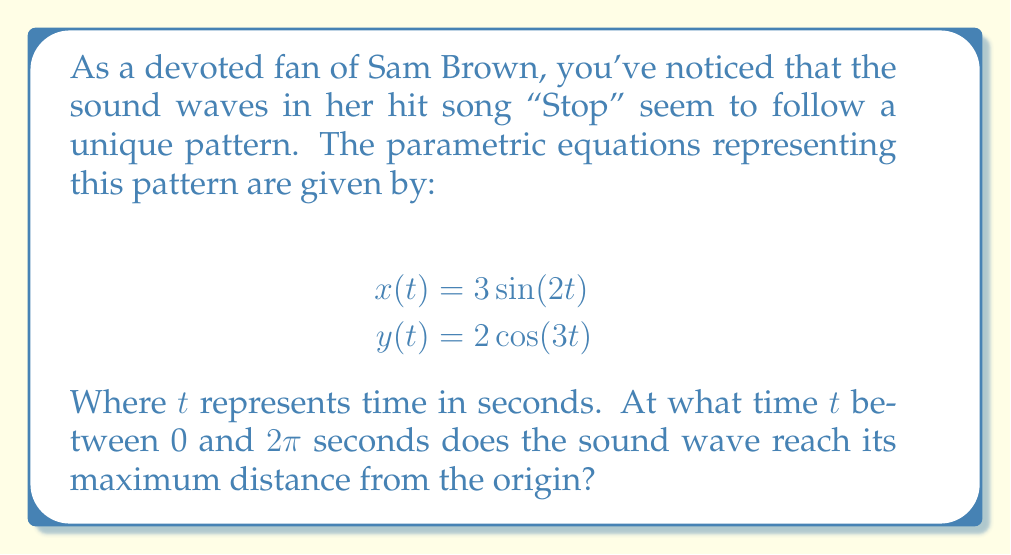Show me your answer to this math problem. To solve this problem, we need to follow these steps:

1) The distance from the origin at any time $t$ is given by:
   $$r(t) = \sqrt{x(t)^2 + y(t)^2}$$

2) Substituting the given equations:
   $$r(t) = \sqrt{(3\sin(2t))^2 + (2\cos(3t))^2}$$

3) Simplify:
   $$r(t) = \sqrt{9\sin^2(2t) + 4\cos^2(3t)}$$

4) To find the maximum value of $r(t)$, we need to find where its derivative equals zero. However, this is a complex function to differentiate.

5) Instead, we can observe that:
   $0 \leq \sin^2(2t) \leq 1$ and $0 \leq \cos^2(3t) \leq 1$ for all $t$

6) Therefore, the maximum value of $r(t)$ will occur when both $\sin^2(2t)$ and $\cos^2(3t)$ are at their maximum values of 1.

7) The maximum possible value of $r(t)$ is:
   $$r_{max} = \sqrt{9(1) + 4(1)} = \sqrt{13}$$

8) This occurs when $\sin^2(2t) = 1$ and $\cos^2(3t) = 1$ simultaneously.

9) $\sin^2(2t) = 1$ when $2t = \frac{\pi}{2}$ or $t = \frac{\pi}{4}$
   $\cos^2(3t) = 1$ when $3t = 0$ or $t = 0$

10) The first time between 0 and $2\pi$ when both conditions are met (approximately) is at $t = \frac{\pi}{4}$ seconds.
Answer: The sound wave reaches its maximum distance from the origin at approximately $t = \frac{\pi}{4} \approx 0.7854$ seconds. 